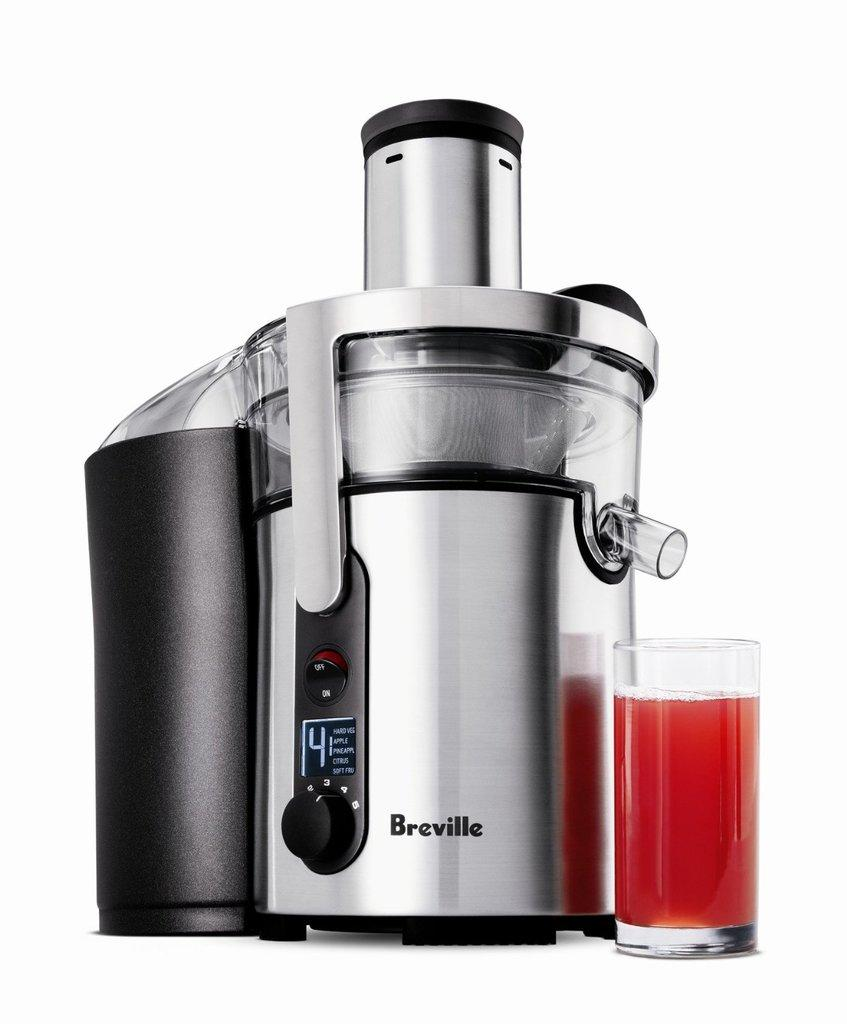<image>
Render a clear and concise summary of the photo. A silver and black electronic juicer made by Breville. 